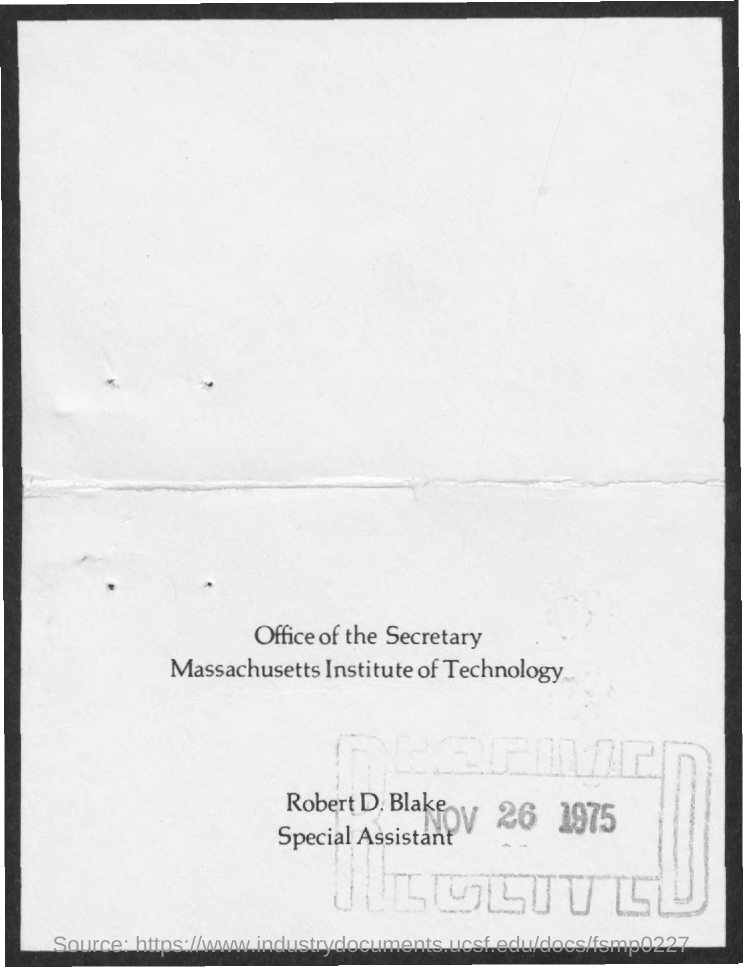What is the received date mentioned ?
Make the answer very short. NOV 26 1975. What is the name of the institute mentioned ?
Ensure brevity in your answer.  MASSACHUSETTS INSTITUTE OF TECHNOLOGY. What is the designation of robert d. blake ?
Your response must be concise. SPECIAL ASSISTANT. 